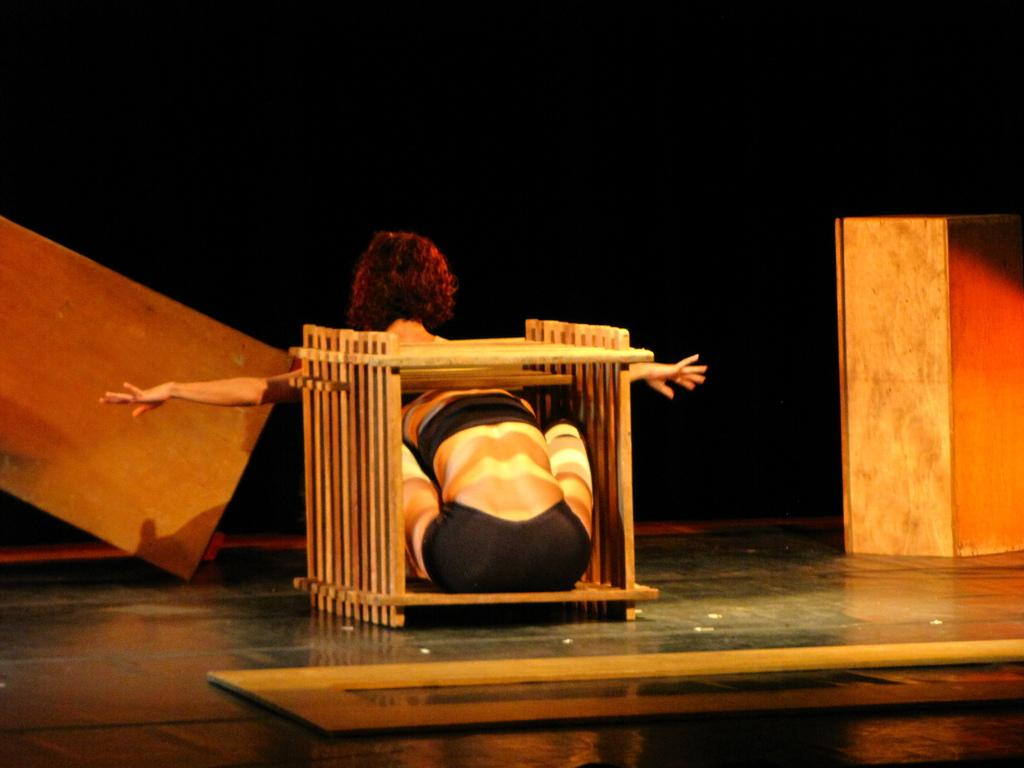What is the main subject in the center of the image? There is a person inside a box in the center of the image. Can you describe the background of the image? There is a lady in the background of the image, and cardboard boxes are also visible. What is the surface that the person and the lady are standing on? There is a floor at the bottom of the image. What type of light is being used to illuminate the class in the image? There is no class or any indication of a specific type of light in the image. 